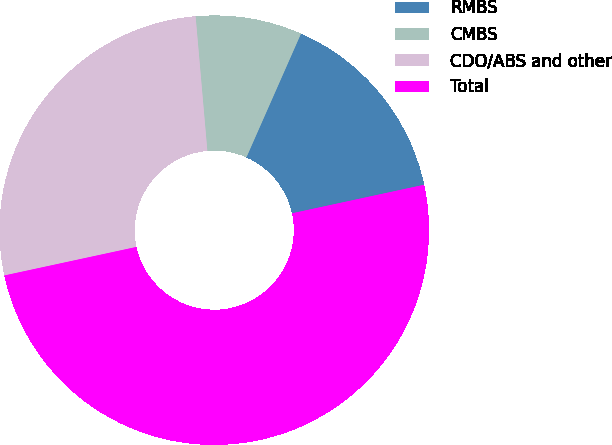Convert chart. <chart><loc_0><loc_0><loc_500><loc_500><pie_chart><fcel>RMBS<fcel>CMBS<fcel>CDO/ABS and other<fcel>Total<nl><fcel>15.0%<fcel>8.0%<fcel>27.0%<fcel>50.0%<nl></chart> 